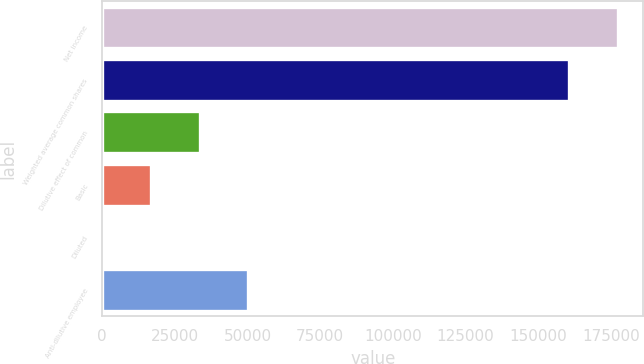Convert chart to OTSL. <chart><loc_0><loc_0><loc_500><loc_500><bar_chart><fcel>Net income<fcel>Weighted average common shares<fcel>Dilutive effect of common<fcel>Basic<fcel>Diluted<fcel>Anti-dilutive employee<nl><fcel>177288<fcel>160520<fcel>33537.1<fcel>16769.1<fcel>1.15<fcel>50305.1<nl></chart> 